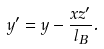<formula> <loc_0><loc_0><loc_500><loc_500>y ^ { \prime } = y - \frac { x z ^ { \prime } } { l _ { B } } .</formula> 